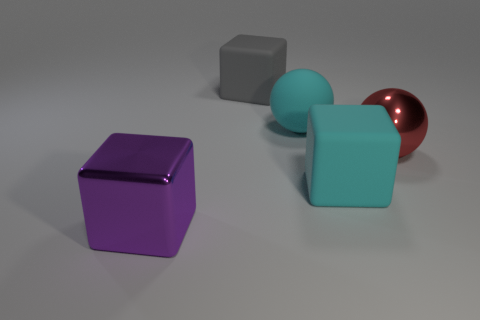Is there anything else that is the same color as the matte sphere?
Your response must be concise. Yes. There is a purple object that is the same shape as the gray thing; what material is it?
Offer a very short reply. Metal. How many tiny green rubber objects are the same shape as the large purple metal object?
Ensure brevity in your answer.  0. There is a purple shiny object; is its shape the same as the metallic object on the right side of the cyan matte ball?
Make the answer very short. No. There is a gray matte object; what number of blocks are right of it?
Ensure brevity in your answer.  1. Is there a red thing of the same size as the cyan cube?
Provide a short and direct response. Yes. There is a shiny object that is left of the big gray thing; is its shape the same as the gray thing?
Your answer should be compact. Yes. The large rubber sphere has what color?
Give a very brief answer. Cyan. What is the shape of the rubber object that is the same color as the rubber ball?
Provide a short and direct response. Cube. Are any gray matte spheres visible?
Your answer should be very brief. No. 